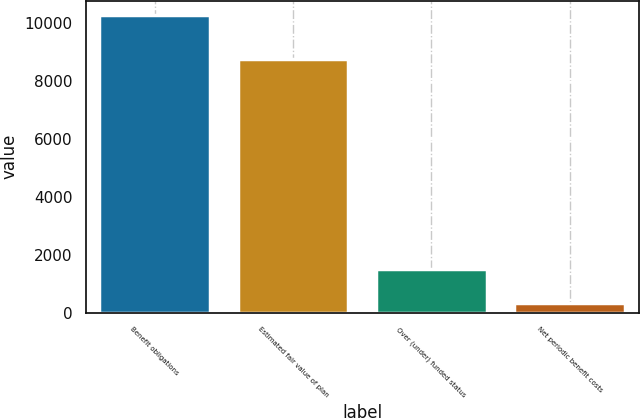Convert chart. <chart><loc_0><loc_0><loc_500><loc_500><bar_chart><fcel>Benefit obligations<fcel>Estimated fair value of plan<fcel>Over (under) funded status<fcel>Net periodic benefit costs<nl><fcel>10262<fcel>8750<fcel>1512<fcel>346<nl></chart> 